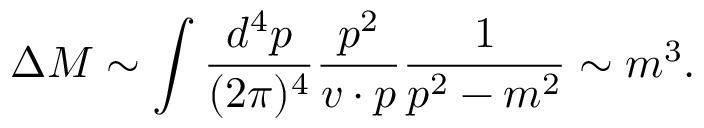Convert formula to latex. <formula><loc_0><loc_0><loc_500><loc_500>\Delta M \sim \int { \frac { d ^ { 4 } p } { ( 2 \pi ) ^ { 4 } } } { \frac { p ^ { 2 } } { v \cdot p } } { \frac { 1 } { p ^ { 2 } - m ^ { 2 } } } \sim m ^ { 3 } .</formula> 